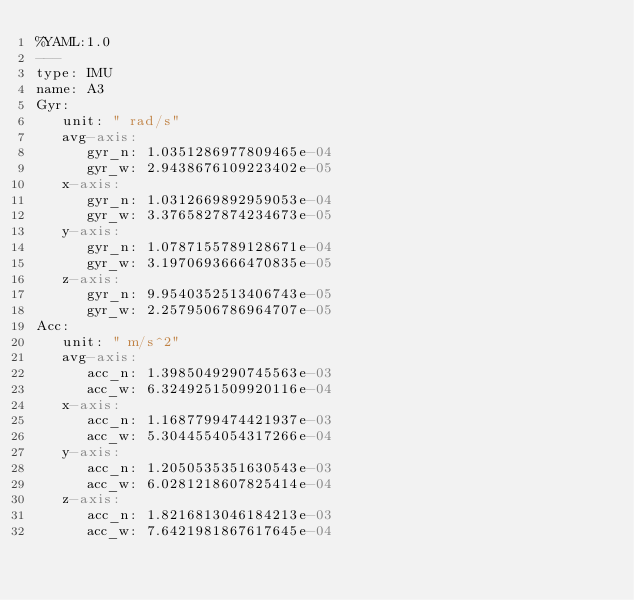<code> <loc_0><loc_0><loc_500><loc_500><_YAML_>%YAML:1.0
---
type: IMU
name: A3
Gyr:
   unit: " rad/s"
   avg-axis:
      gyr_n: 1.0351286977809465e-04
      gyr_w: 2.9438676109223402e-05
   x-axis:
      gyr_n: 1.0312669892959053e-04
      gyr_w: 3.3765827874234673e-05
   y-axis:
      gyr_n: 1.0787155789128671e-04
      gyr_w: 3.1970693666470835e-05
   z-axis:
      gyr_n: 9.9540352513406743e-05
      gyr_w: 2.2579506786964707e-05
Acc:
   unit: " m/s^2"
   avg-axis:
      acc_n: 1.3985049290745563e-03
      acc_w: 6.3249251509920116e-04
   x-axis:
      acc_n: 1.1687799474421937e-03
      acc_w: 5.3044554054317266e-04
   y-axis:
      acc_n: 1.2050535351630543e-03
      acc_w: 6.0281218607825414e-04
   z-axis:
      acc_n: 1.8216813046184213e-03
      acc_w: 7.6421981867617645e-04
</code> 